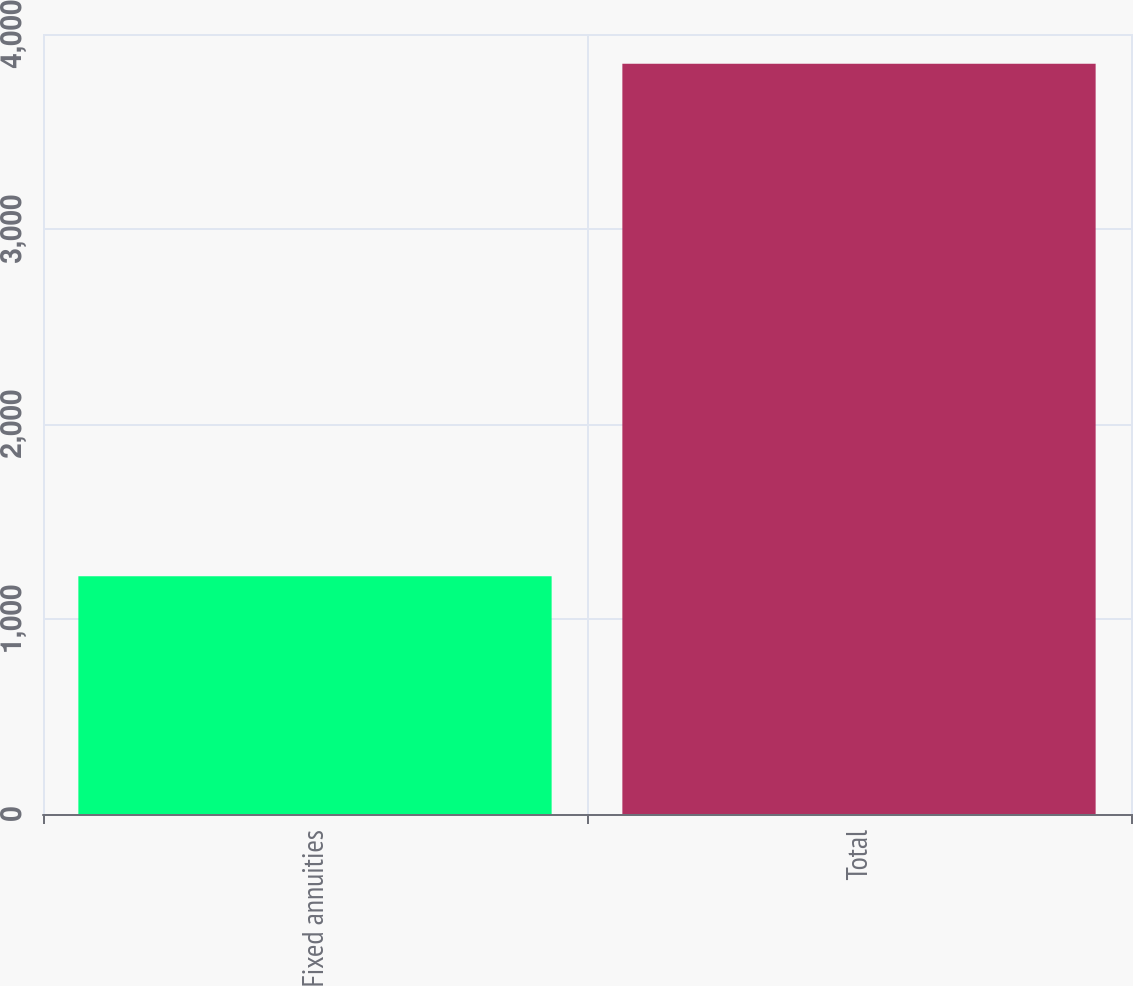<chart> <loc_0><loc_0><loc_500><loc_500><bar_chart><fcel>Fixed annuities<fcel>Total<nl><fcel>1219<fcel>3848<nl></chart> 